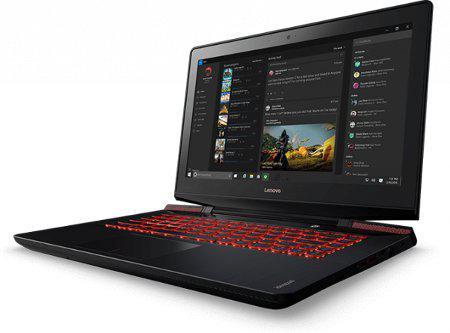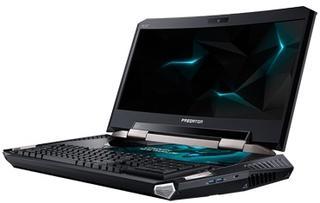The first image is the image on the left, the second image is the image on the right. Analyze the images presented: Is the assertion "The laptops are facing towards the left side of the image." valid? Answer yes or no. Yes. 